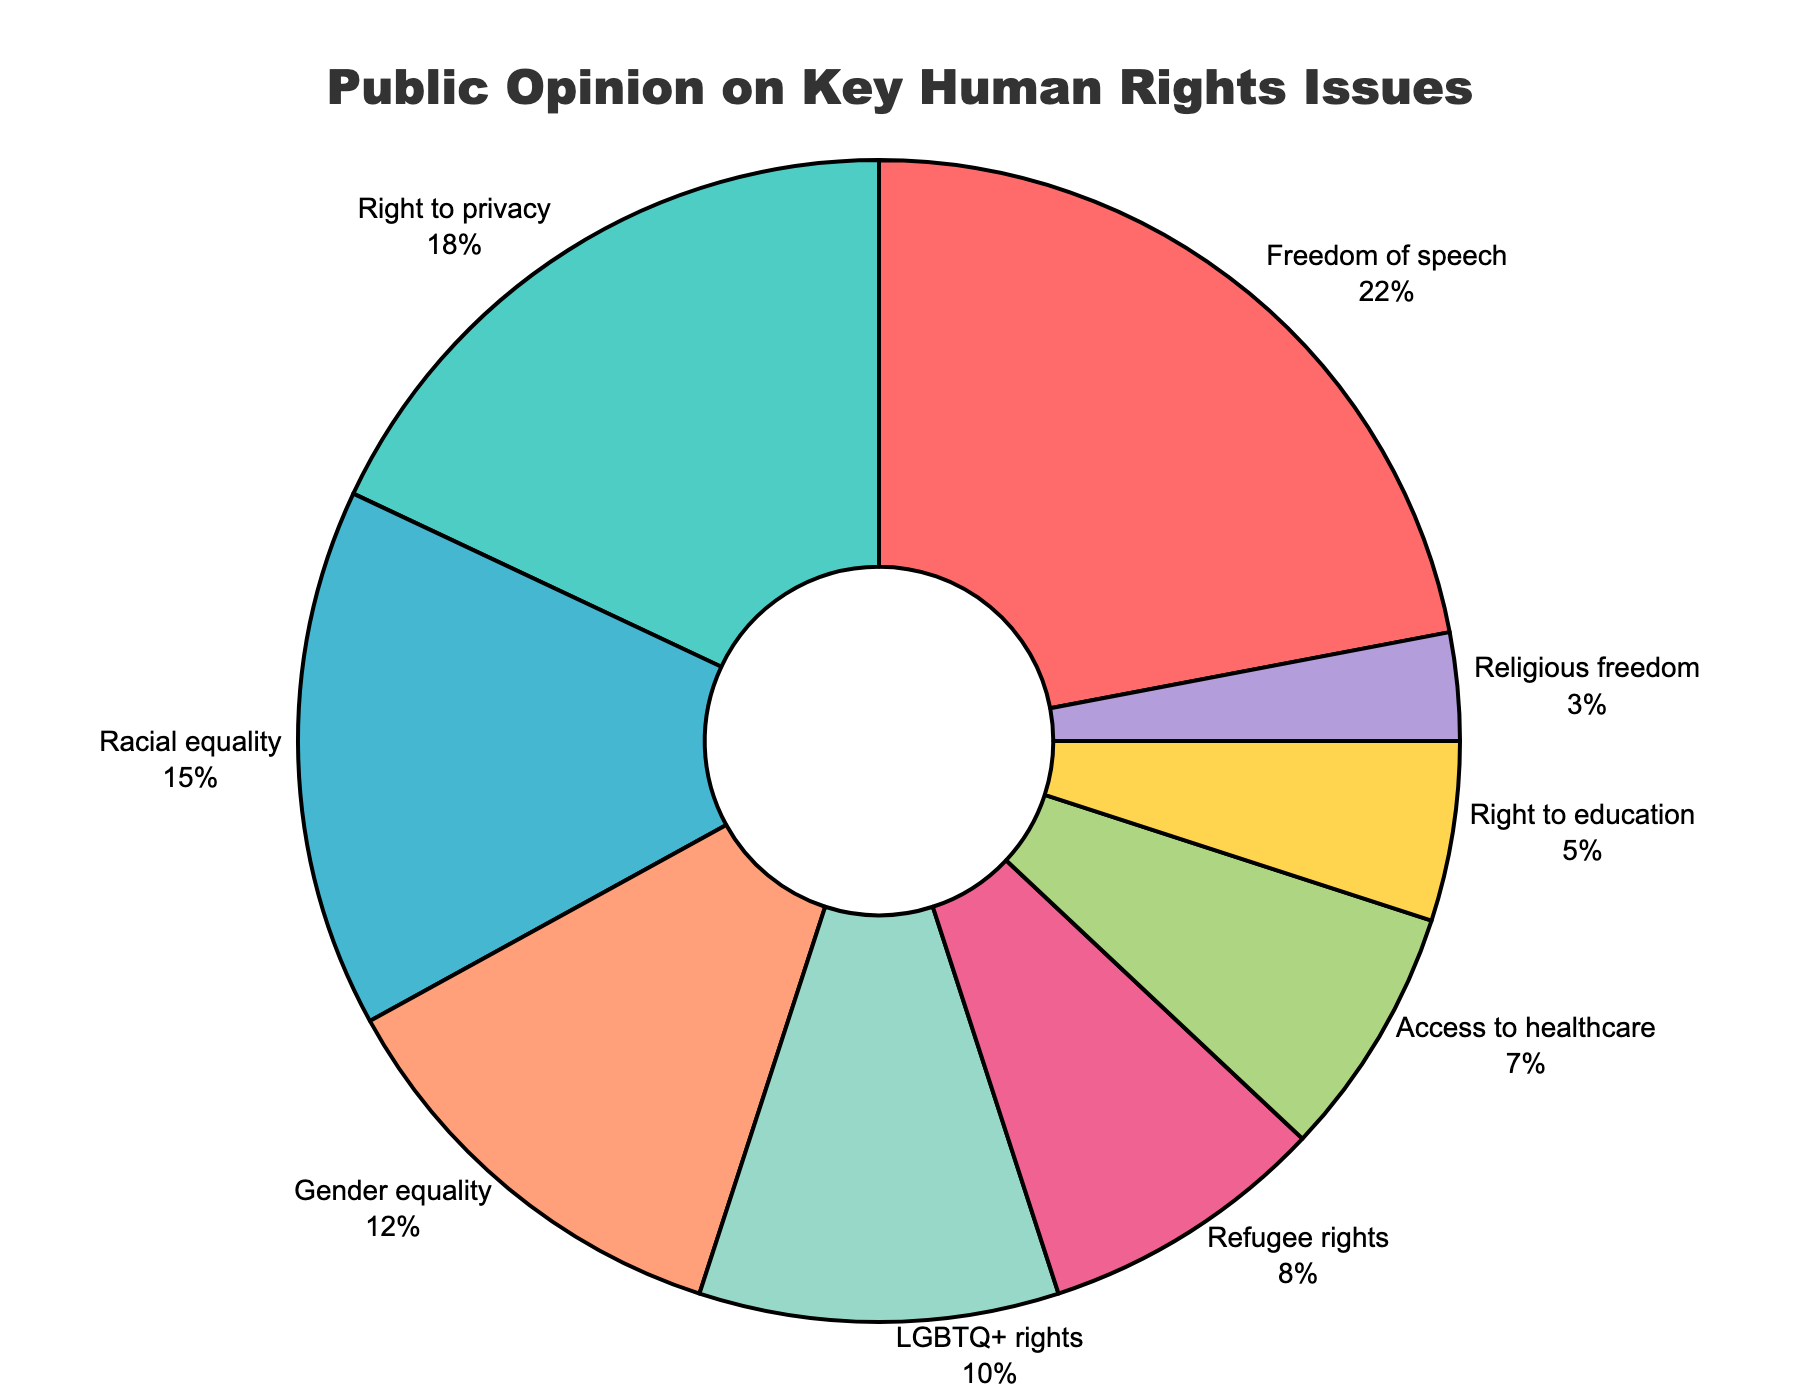What is the most significant human rights issue according to public opinion? From the pie chart, the issue with the largest percentage slice is Freedom of Speech, which occupies 22% of the pie chart
Answer: Freedom of Speech What is the combined percentage of public opinion for Racial Equality and Gender Equality? Looking at the pie chart, Racial Equality is 15% and Gender Equality is 12%. Adding these together: 15% + 12% = 27%
Answer: 27% Which issue has more public support: LGBTQ+ rights or Refugee rights? Comparing the slices, LGBTQ+ rights have 10% while Refugee rights have 8%. Therefore, LGBTQ+ rights have more support
Answer: LGBTQ+ rights How much more support does Freedom of Speech have compared to Religious Freedom? Freedom of Speech has a 22% slice while Religious Freedom has 3%. The difference is 22% - 3% = 19%
Answer: 19% What is the average percentage of public opinion for Right to Privacy, Access to Healthcare, and Right to Education? The percentages are Right to Privacy (18%), Access to Healthcare (7%), and Right to Education (5%). The sum is 18% + 7% + 5% = 30%. Then, 30% / 3 = 10%
Answer: 10% Which issue has the smallest slice in the pie chart? The pie chart shows the smallest slice belongs to Religious Freedom with 3%
Answer: Religious Freedom If you combine the percentages of Freedom of Speech, Right to Privacy, and Racial Equality, what part of the pie chart do they represent? Adding their percentages together: Freedom of Speech (22%) + Right to Privacy (18%) + Racial Equality (15%) = 55%
Answer: 55% How does the percentage of Gender Equality compare to the percentage of Right to Privacy? Gender Equality has 12% while Right to Privacy has 18%. Gender Equality has a smaller percentage
Answer: Gender Equality is smaller What are the visual colors used to represent Right to Privacy and Refugee Rights? The pie chart represents Right to Privacy with a green slice and Refugee Rights with a pink slice.
Answer: Green and Pink 